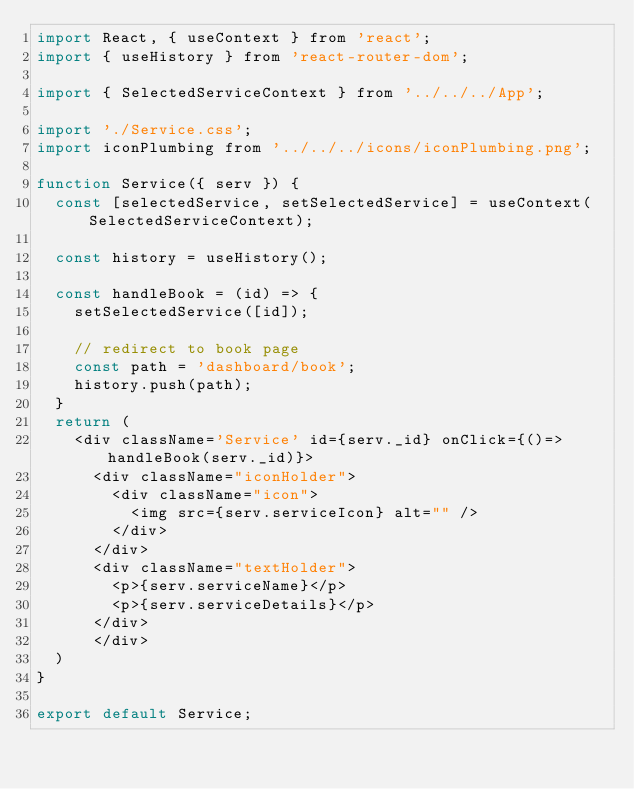<code> <loc_0><loc_0><loc_500><loc_500><_JavaScript_>import React, { useContext } from 'react';
import { useHistory } from 'react-router-dom';

import { SelectedServiceContext } from '../../../App';

import './Service.css';
import iconPlumbing from '../../../icons/iconPlumbing.png';

function Service({ serv }) {
	const [selectedService, setSelectedService] = useContext(SelectedServiceContext);

	const history = useHistory();

	const handleBook = (id) => {
		setSelectedService([id]);

		// redirect to book page
		const path = 'dashboard/book'; 
		history.push(path);
	}
	return (
		<div className='Service' id={serv._id} onClick={()=>handleBook(serv._id)}>
			<div className="iconHolder">
				<div className="icon">
					<img src={serv.serviceIcon} alt="" />
				</div>
			</div>
			<div className="textHolder">
				<p>{serv.serviceName}</p>
				<p>{serv.serviceDetails}</p>
			</div>
			</div>
	)
}

export default Service;</code> 